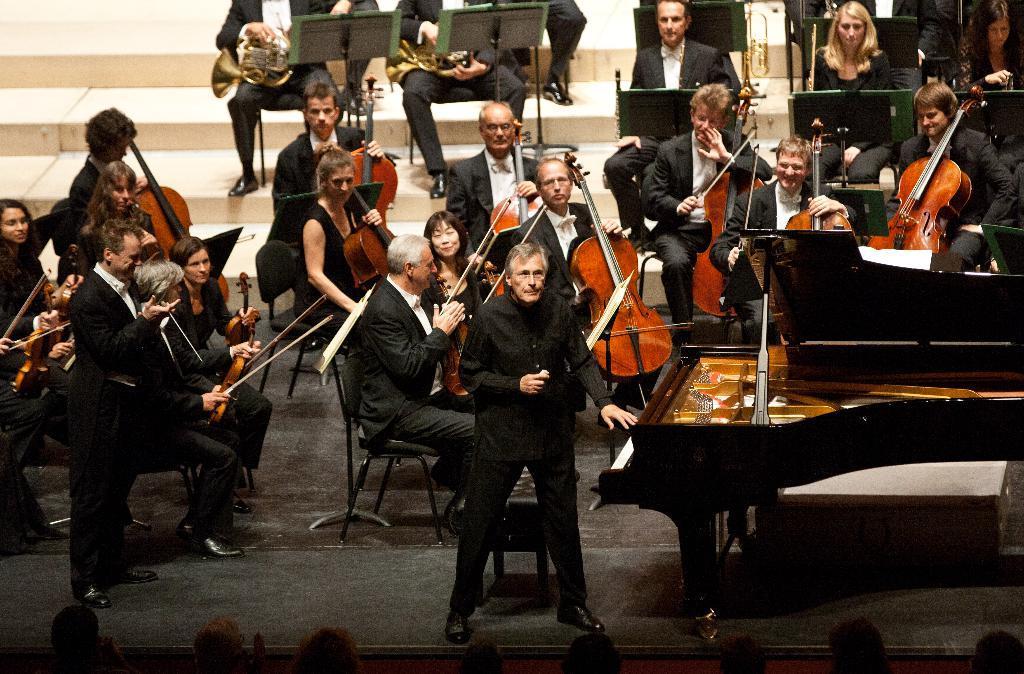In one or two sentences, can you explain what this image depicts? Group of people are there playing violins other people are playing saxophones. One person is standing in front of the piano another person is just standing. 